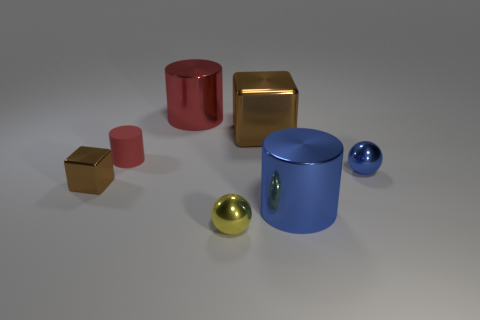Subtract all cyan balls. How many red cylinders are left? 2 Add 1 small red things. How many objects exist? 8 Subtract all tiny red rubber cylinders. How many cylinders are left? 2 Subtract 1 cylinders. How many cylinders are left? 2 Subtract all cyan cylinders. Subtract all red spheres. How many cylinders are left? 3 Subtract all cylinders. How many objects are left? 4 Add 5 tiny red matte objects. How many tiny red matte objects exist? 6 Subtract 0 gray spheres. How many objects are left? 7 Subtract all small spheres. Subtract all big cubes. How many objects are left? 4 Add 7 large blue cylinders. How many large blue cylinders are left? 8 